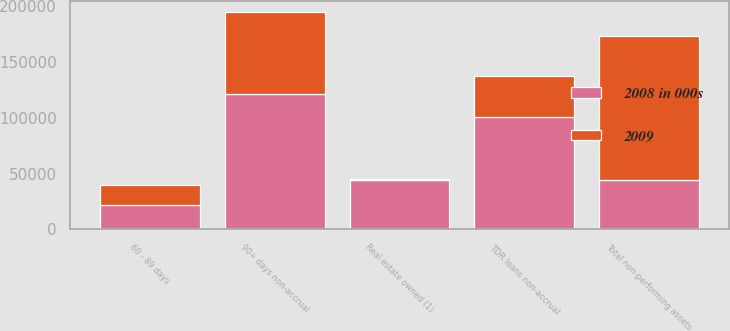Convert chart. <chart><loc_0><loc_0><loc_500><loc_500><stacked_bar_chart><ecel><fcel>60 - 89 days<fcel>90+ days non-accrual<fcel>TDR loans non-accrual<fcel>Real estate owned (1)<fcel>Total non-performing assets<nl><fcel>2008 in 000s<fcel>21415<fcel>121685<fcel>100697<fcel>44533<fcel>44533<nl><fcel>2009<fcel>18182<fcel>73600<fcel>37159<fcel>350<fcel>129291<nl></chart> 